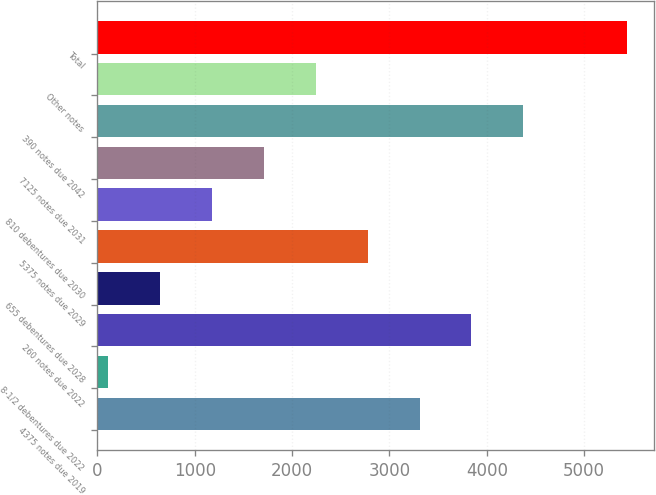<chart> <loc_0><loc_0><loc_500><loc_500><bar_chart><fcel>4375 notes due 2019<fcel>8-1/2 debentures due 2022<fcel>260 notes due 2022<fcel>655 debentures due 2028<fcel>5375 notes due 2029<fcel>810 debentures due 2030<fcel>7125 notes due 2031<fcel>390 notes due 2042<fcel>Other notes<fcel>Total<nl><fcel>3309<fcel>105<fcel>3843<fcel>639<fcel>2775<fcel>1173<fcel>1707<fcel>4377<fcel>2241<fcel>5445<nl></chart> 